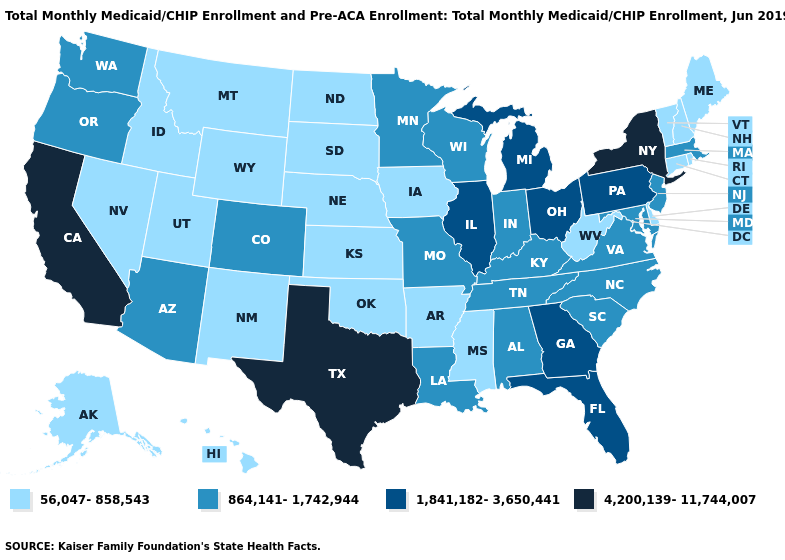Does Oregon have the lowest value in the West?
Give a very brief answer. No. Which states hav the highest value in the MidWest?
Answer briefly. Illinois, Michigan, Ohio. What is the highest value in the South ?
Concise answer only. 4,200,139-11,744,007. What is the value of Alabama?
Give a very brief answer. 864,141-1,742,944. Does Michigan have the same value as Arkansas?
Be succinct. No. Name the states that have a value in the range 864,141-1,742,944?
Be succinct. Alabama, Arizona, Colorado, Indiana, Kentucky, Louisiana, Maryland, Massachusetts, Minnesota, Missouri, New Jersey, North Carolina, Oregon, South Carolina, Tennessee, Virginia, Washington, Wisconsin. Name the states that have a value in the range 4,200,139-11,744,007?
Keep it brief. California, New York, Texas. What is the highest value in states that border Nevada?
Write a very short answer. 4,200,139-11,744,007. What is the value of Wisconsin?
Write a very short answer. 864,141-1,742,944. Is the legend a continuous bar?
Keep it brief. No. What is the highest value in states that border South Carolina?
Answer briefly. 1,841,182-3,650,441. Does New York have the highest value in the USA?
Be succinct. Yes. How many symbols are there in the legend?
Be succinct. 4. What is the value of Hawaii?
Be succinct. 56,047-858,543. Does Indiana have a higher value than Illinois?
Be succinct. No. 